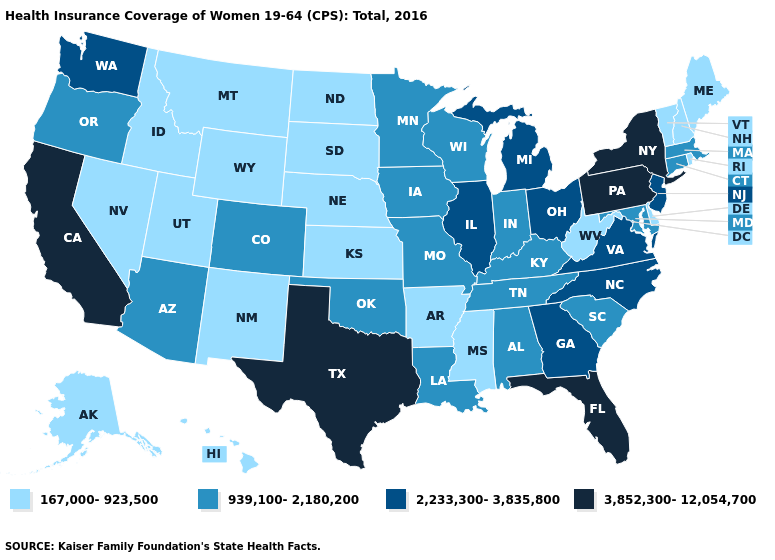Name the states that have a value in the range 939,100-2,180,200?
Answer briefly. Alabama, Arizona, Colorado, Connecticut, Indiana, Iowa, Kentucky, Louisiana, Maryland, Massachusetts, Minnesota, Missouri, Oklahoma, Oregon, South Carolina, Tennessee, Wisconsin. What is the value of Nevada?
Write a very short answer. 167,000-923,500. Which states hav the highest value in the Northeast?
Concise answer only. New York, Pennsylvania. Among the states that border Pennsylvania , which have the highest value?
Answer briefly. New York. Which states have the lowest value in the Northeast?
Be succinct. Maine, New Hampshire, Rhode Island, Vermont. Does the map have missing data?
Keep it brief. No. Does Iowa have a higher value than Massachusetts?
Be succinct. No. What is the value of Indiana?
Give a very brief answer. 939,100-2,180,200. Name the states that have a value in the range 3,852,300-12,054,700?
Concise answer only. California, Florida, New York, Pennsylvania, Texas. Name the states that have a value in the range 939,100-2,180,200?
Be succinct. Alabama, Arizona, Colorado, Connecticut, Indiana, Iowa, Kentucky, Louisiana, Maryland, Massachusetts, Minnesota, Missouri, Oklahoma, Oregon, South Carolina, Tennessee, Wisconsin. What is the lowest value in the South?
Keep it brief. 167,000-923,500. Which states hav the highest value in the South?
Quick response, please. Florida, Texas. Among the states that border Connecticut , which have the lowest value?
Write a very short answer. Rhode Island. Does Alabama have the highest value in the USA?
Be succinct. No. Which states have the lowest value in the Northeast?
Short answer required. Maine, New Hampshire, Rhode Island, Vermont. 